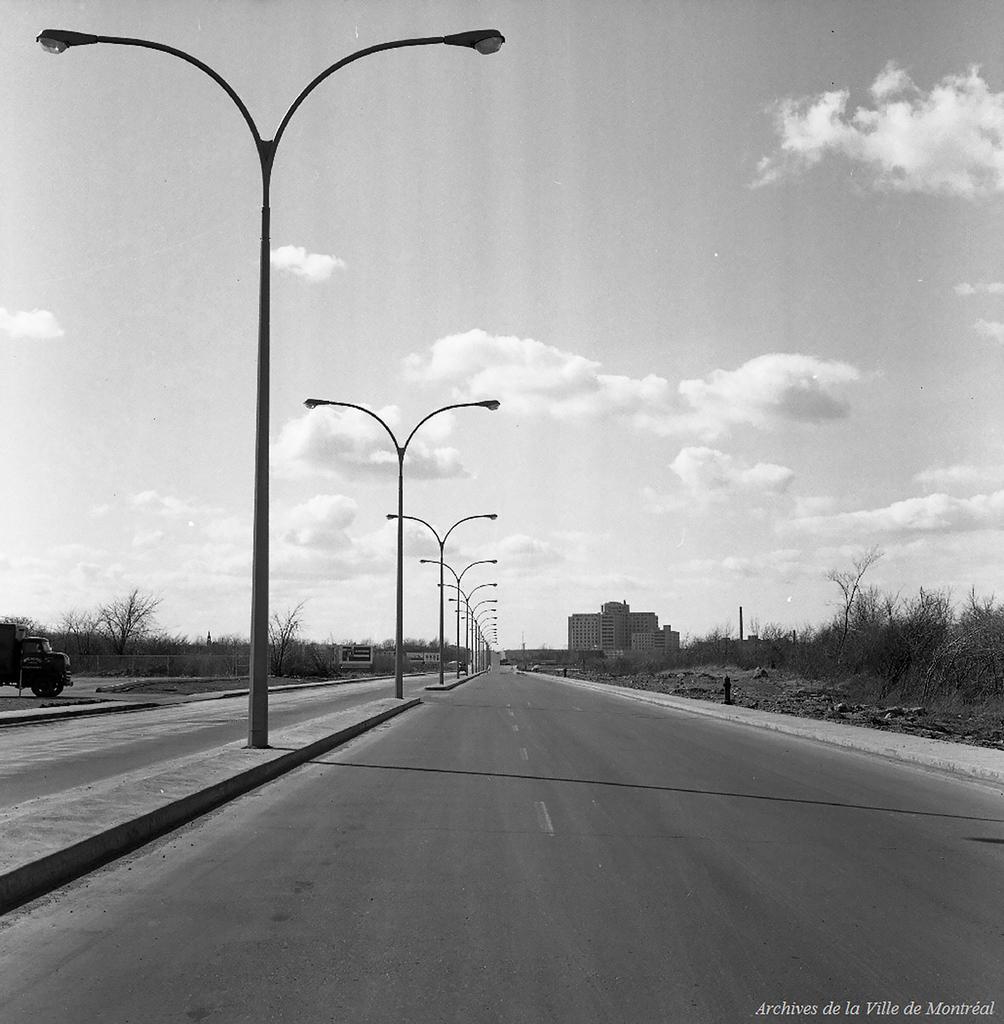Describe this image in one or two sentences. It is the black and white image in which there is a road in the middle. There are poles with the lights on the footpath. At the top there is the sky. On the right side there is a building in the background and there are trees beside the road. 